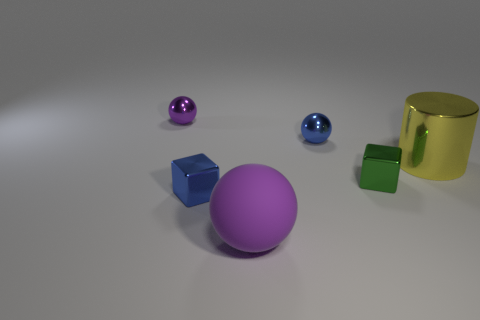Is the number of tiny gray metal cylinders less than the number of metallic cylinders?
Your answer should be very brief. Yes. The small metal ball that is in front of the tiny metallic sphere to the left of the blue metallic block is what color?
Your answer should be very brief. Blue. There is a tiny blue object that is the same shape as the green metal thing; what is its material?
Offer a terse response. Metal. What number of rubber things are blue spheres or balls?
Give a very brief answer. 1. Does the purple object that is in front of the big metal cylinder have the same material as the small ball in front of the small purple shiny object?
Give a very brief answer. No. Are any tiny metallic blocks visible?
Provide a short and direct response. Yes. There is a blue metal object on the right side of the large purple matte thing; does it have the same shape as the purple thing that is in front of the tiny purple ball?
Your answer should be very brief. Yes. Are there any small purple spheres that have the same material as the small green thing?
Provide a succinct answer. Yes. Does the blue thing that is in front of the yellow cylinder have the same material as the yellow cylinder?
Your answer should be very brief. Yes. Is the number of big metallic things in front of the blue metal cube greater than the number of blue objects to the right of the purple shiny sphere?
Offer a very short reply. No. 